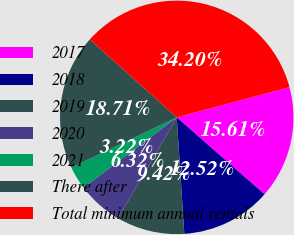<chart> <loc_0><loc_0><loc_500><loc_500><pie_chart><fcel>2017<fcel>2018<fcel>2019<fcel>2020<fcel>2021<fcel>There after<fcel>Total minimum annual rentals<nl><fcel>15.61%<fcel>12.52%<fcel>9.42%<fcel>6.32%<fcel>3.22%<fcel>18.71%<fcel>34.2%<nl></chart> 